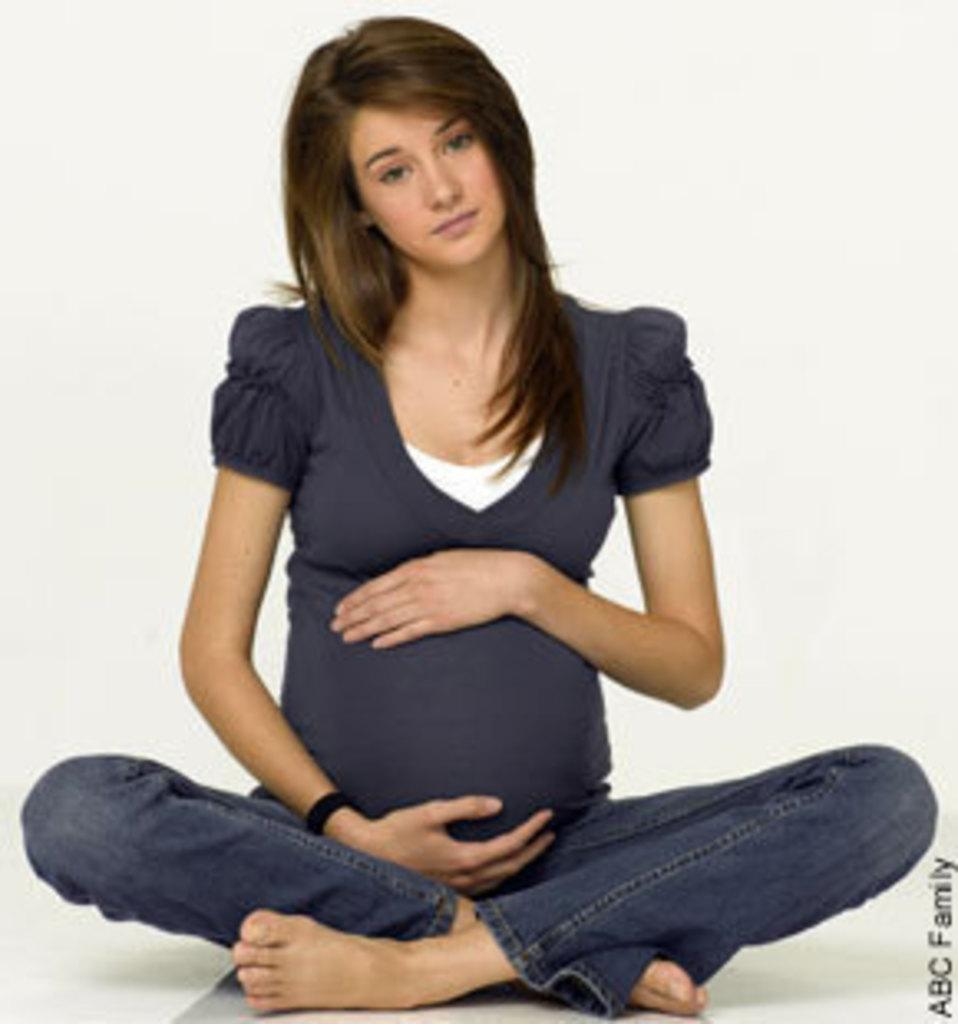What is the main subject of the image? There is a pregnant lady in the image. What is the pregnant lady doing in the image? The pregnant lady is sitting on the floor. What can be seen in the background of the image? There is a wall in the background of the image. How many trees are visible in the image? There are no trees visible in the image; it only shows a pregnant lady sitting on the floor with a wall in the background. 